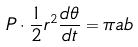Convert formula to latex. <formula><loc_0><loc_0><loc_500><loc_500>P \cdot \frac { 1 } { 2 } r ^ { 2 } \frac { d \theta } { d t } = \pi a b</formula> 